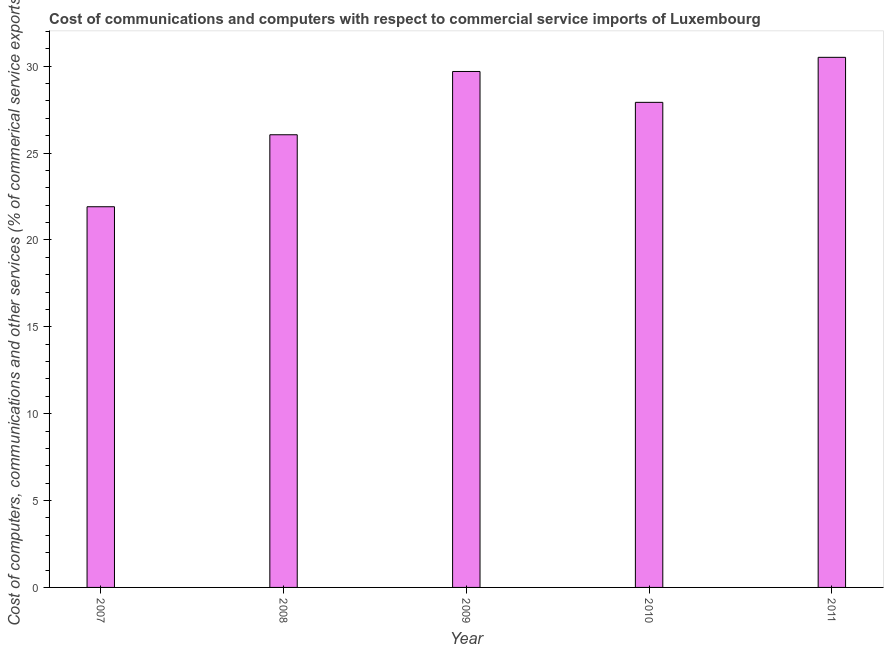What is the title of the graph?
Offer a very short reply. Cost of communications and computers with respect to commercial service imports of Luxembourg. What is the label or title of the X-axis?
Your response must be concise. Year. What is the label or title of the Y-axis?
Provide a short and direct response. Cost of computers, communications and other services (% of commerical service exports). What is the cost of communications in 2011?
Provide a short and direct response. 30.51. Across all years, what is the maximum cost of communications?
Offer a terse response. 30.51. Across all years, what is the minimum cost of communications?
Keep it short and to the point. 21.91. What is the sum of the cost of communications?
Provide a short and direct response. 136.1. What is the difference between the  computer and other services in 2007 and 2008?
Provide a short and direct response. -4.14. What is the average  computer and other services per year?
Ensure brevity in your answer.  27.22. What is the median  computer and other services?
Offer a terse response. 27.92. Do a majority of the years between 2011 and 2010 (inclusive) have  computer and other services greater than 10 %?
Ensure brevity in your answer.  No. Is the cost of communications in 2010 less than that in 2011?
Offer a very short reply. Yes. What is the difference between the highest and the second highest  computer and other services?
Your response must be concise. 0.81. In how many years, is the  computer and other services greater than the average  computer and other services taken over all years?
Offer a terse response. 3. Are all the bars in the graph horizontal?
Your response must be concise. No. How many years are there in the graph?
Offer a terse response. 5. What is the difference between two consecutive major ticks on the Y-axis?
Offer a terse response. 5. What is the Cost of computers, communications and other services (% of commerical service exports) of 2007?
Make the answer very short. 21.91. What is the Cost of computers, communications and other services (% of commerical service exports) in 2008?
Provide a succinct answer. 26.06. What is the Cost of computers, communications and other services (% of commerical service exports) of 2009?
Your answer should be compact. 29.7. What is the Cost of computers, communications and other services (% of commerical service exports) in 2010?
Provide a succinct answer. 27.92. What is the Cost of computers, communications and other services (% of commerical service exports) in 2011?
Ensure brevity in your answer.  30.51. What is the difference between the Cost of computers, communications and other services (% of commerical service exports) in 2007 and 2008?
Provide a short and direct response. -4.14. What is the difference between the Cost of computers, communications and other services (% of commerical service exports) in 2007 and 2009?
Your answer should be compact. -7.79. What is the difference between the Cost of computers, communications and other services (% of commerical service exports) in 2007 and 2010?
Your answer should be very brief. -6.01. What is the difference between the Cost of computers, communications and other services (% of commerical service exports) in 2007 and 2011?
Your answer should be compact. -8.6. What is the difference between the Cost of computers, communications and other services (% of commerical service exports) in 2008 and 2009?
Ensure brevity in your answer.  -3.64. What is the difference between the Cost of computers, communications and other services (% of commerical service exports) in 2008 and 2010?
Your answer should be compact. -1.87. What is the difference between the Cost of computers, communications and other services (% of commerical service exports) in 2008 and 2011?
Provide a short and direct response. -4.46. What is the difference between the Cost of computers, communications and other services (% of commerical service exports) in 2009 and 2010?
Provide a succinct answer. 1.78. What is the difference between the Cost of computers, communications and other services (% of commerical service exports) in 2009 and 2011?
Offer a terse response. -0.81. What is the difference between the Cost of computers, communications and other services (% of commerical service exports) in 2010 and 2011?
Your response must be concise. -2.59. What is the ratio of the Cost of computers, communications and other services (% of commerical service exports) in 2007 to that in 2008?
Keep it short and to the point. 0.84. What is the ratio of the Cost of computers, communications and other services (% of commerical service exports) in 2007 to that in 2009?
Your answer should be compact. 0.74. What is the ratio of the Cost of computers, communications and other services (% of commerical service exports) in 2007 to that in 2010?
Ensure brevity in your answer.  0.79. What is the ratio of the Cost of computers, communications and other services (% of commerical service exports) in 2007 to that in 2011?
Ensure brevity in your answer.  0.72. What is the ratio of the Cost of computers, communications and other services (% of commerical service exports) in 2008 to that in 2009?
Your response must be concise. 0.88. What is the ratio of the Cost of computers, communications and other services (% of commerical service exports) in 2008 to that in 2010?
Provide a succinct answer. 0.93. What is the ratio of the Cost of computers, communications and other services (% of commerical service exports) in 2008 to that in 2011?
Your response must be concise. 0.85. What is the ratio of the Cost of computers, communications and other services (% of commerical service exports) in 2009 to that in 2010?
Keep it short and to the point. 1.06. What is the ratio of the Cost of computers, communications and other services (% of commerical service exports) in 2010 to that in 2011?
Keep it short and to the point. 0.92. 